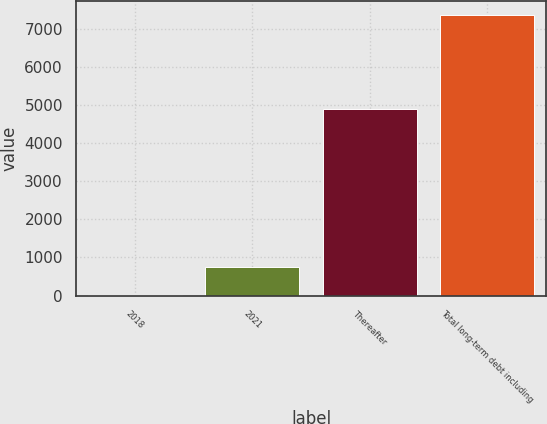Convert chart. <chart><loc_0><loc_0><loc_500><loc_500><bar_chart><fcel>2018<fcel>2021<fcel>Thereafter<fcel>Total long-term debt including<nl><fcel>3<fcel>738.4<fcel>4892<fcel>7357<nl></chart> 